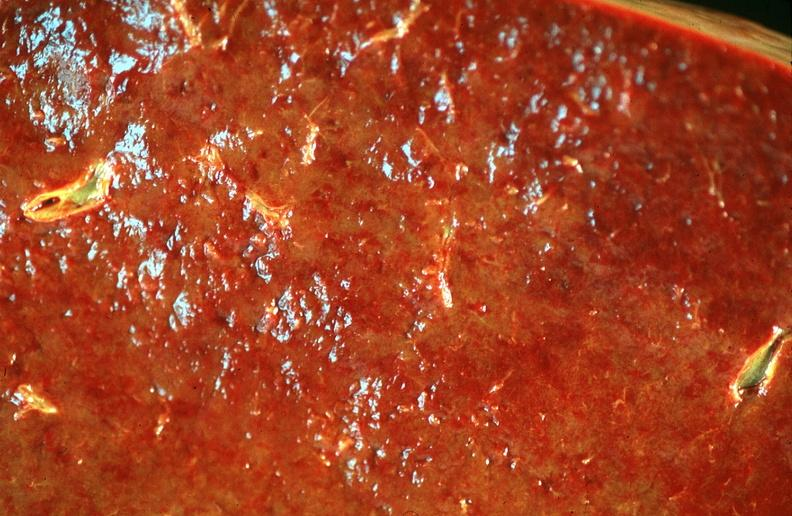s hematologic present?
Answer the question using a single word or phrase. Yes 